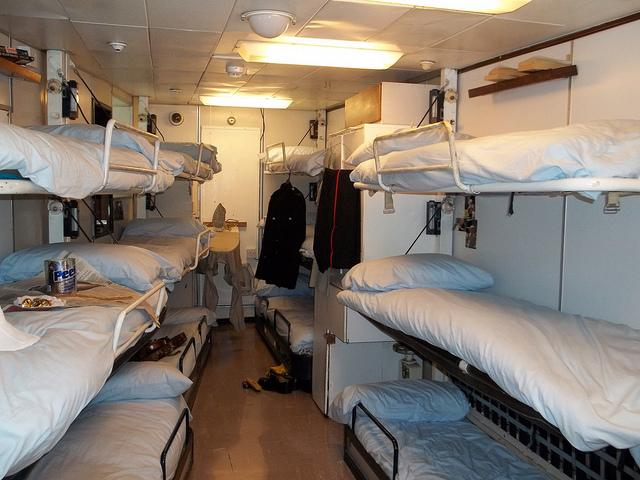Who likely resides here? Please explain your reasoning. army trainees. Army trainees reside here. 